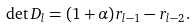Convert formula to latex. <formula><loc_0><loc_0><loc_500><loc_500>\det D _ { l } = ( 1 + \alpha ) r _ { l - 1 } - r _ { l - 2 } .</formula> 